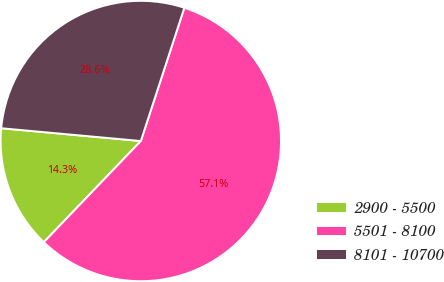<chart> <loc_0><loc_0><loc_500><loc_500><pie_chart><fcel>2900 - 5500<fcel>5501 - 8100<fcel>8101 - 10700<nl><fcel>14.29%<fcel>57.14%<fcel>28.57%<nl></chart> 